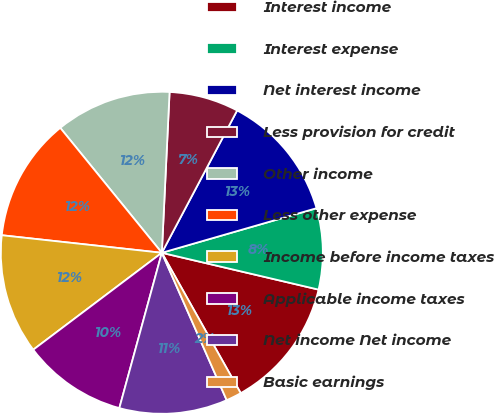Convert chart. <chart><loc_0><loc_0><loc_500><loc_500><pie_chart><fcel>Interest income<fcel>Interest expense<fcel>Net interest income<fcel>Less provision for credit<fcel>Other income<fcel>Less other expense<fcel>Income before income taxes<fcel>Applicable income taxes<fcel>Net income Net income<fcel>Basic earnings<nl><fcel>13.18%<fcel>8.14%<fcel>12.79%<fcel>6.98%<fcel>11.63%<fcel>12.4%<fcel>12.02%<fcel>10.47%<fcel>10.85%<fcel>1.55%<nl></chart> 